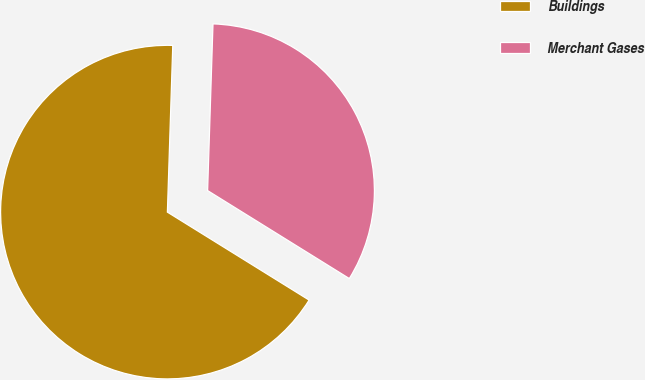Convert chart. <chart><loc_0><loc_0><loc_500><loc_500><pie_chart><fcel>Buildings<fcel>Merchant Gases<nl><fcel>66.67%<fcel>33.33%<nl></chart> 